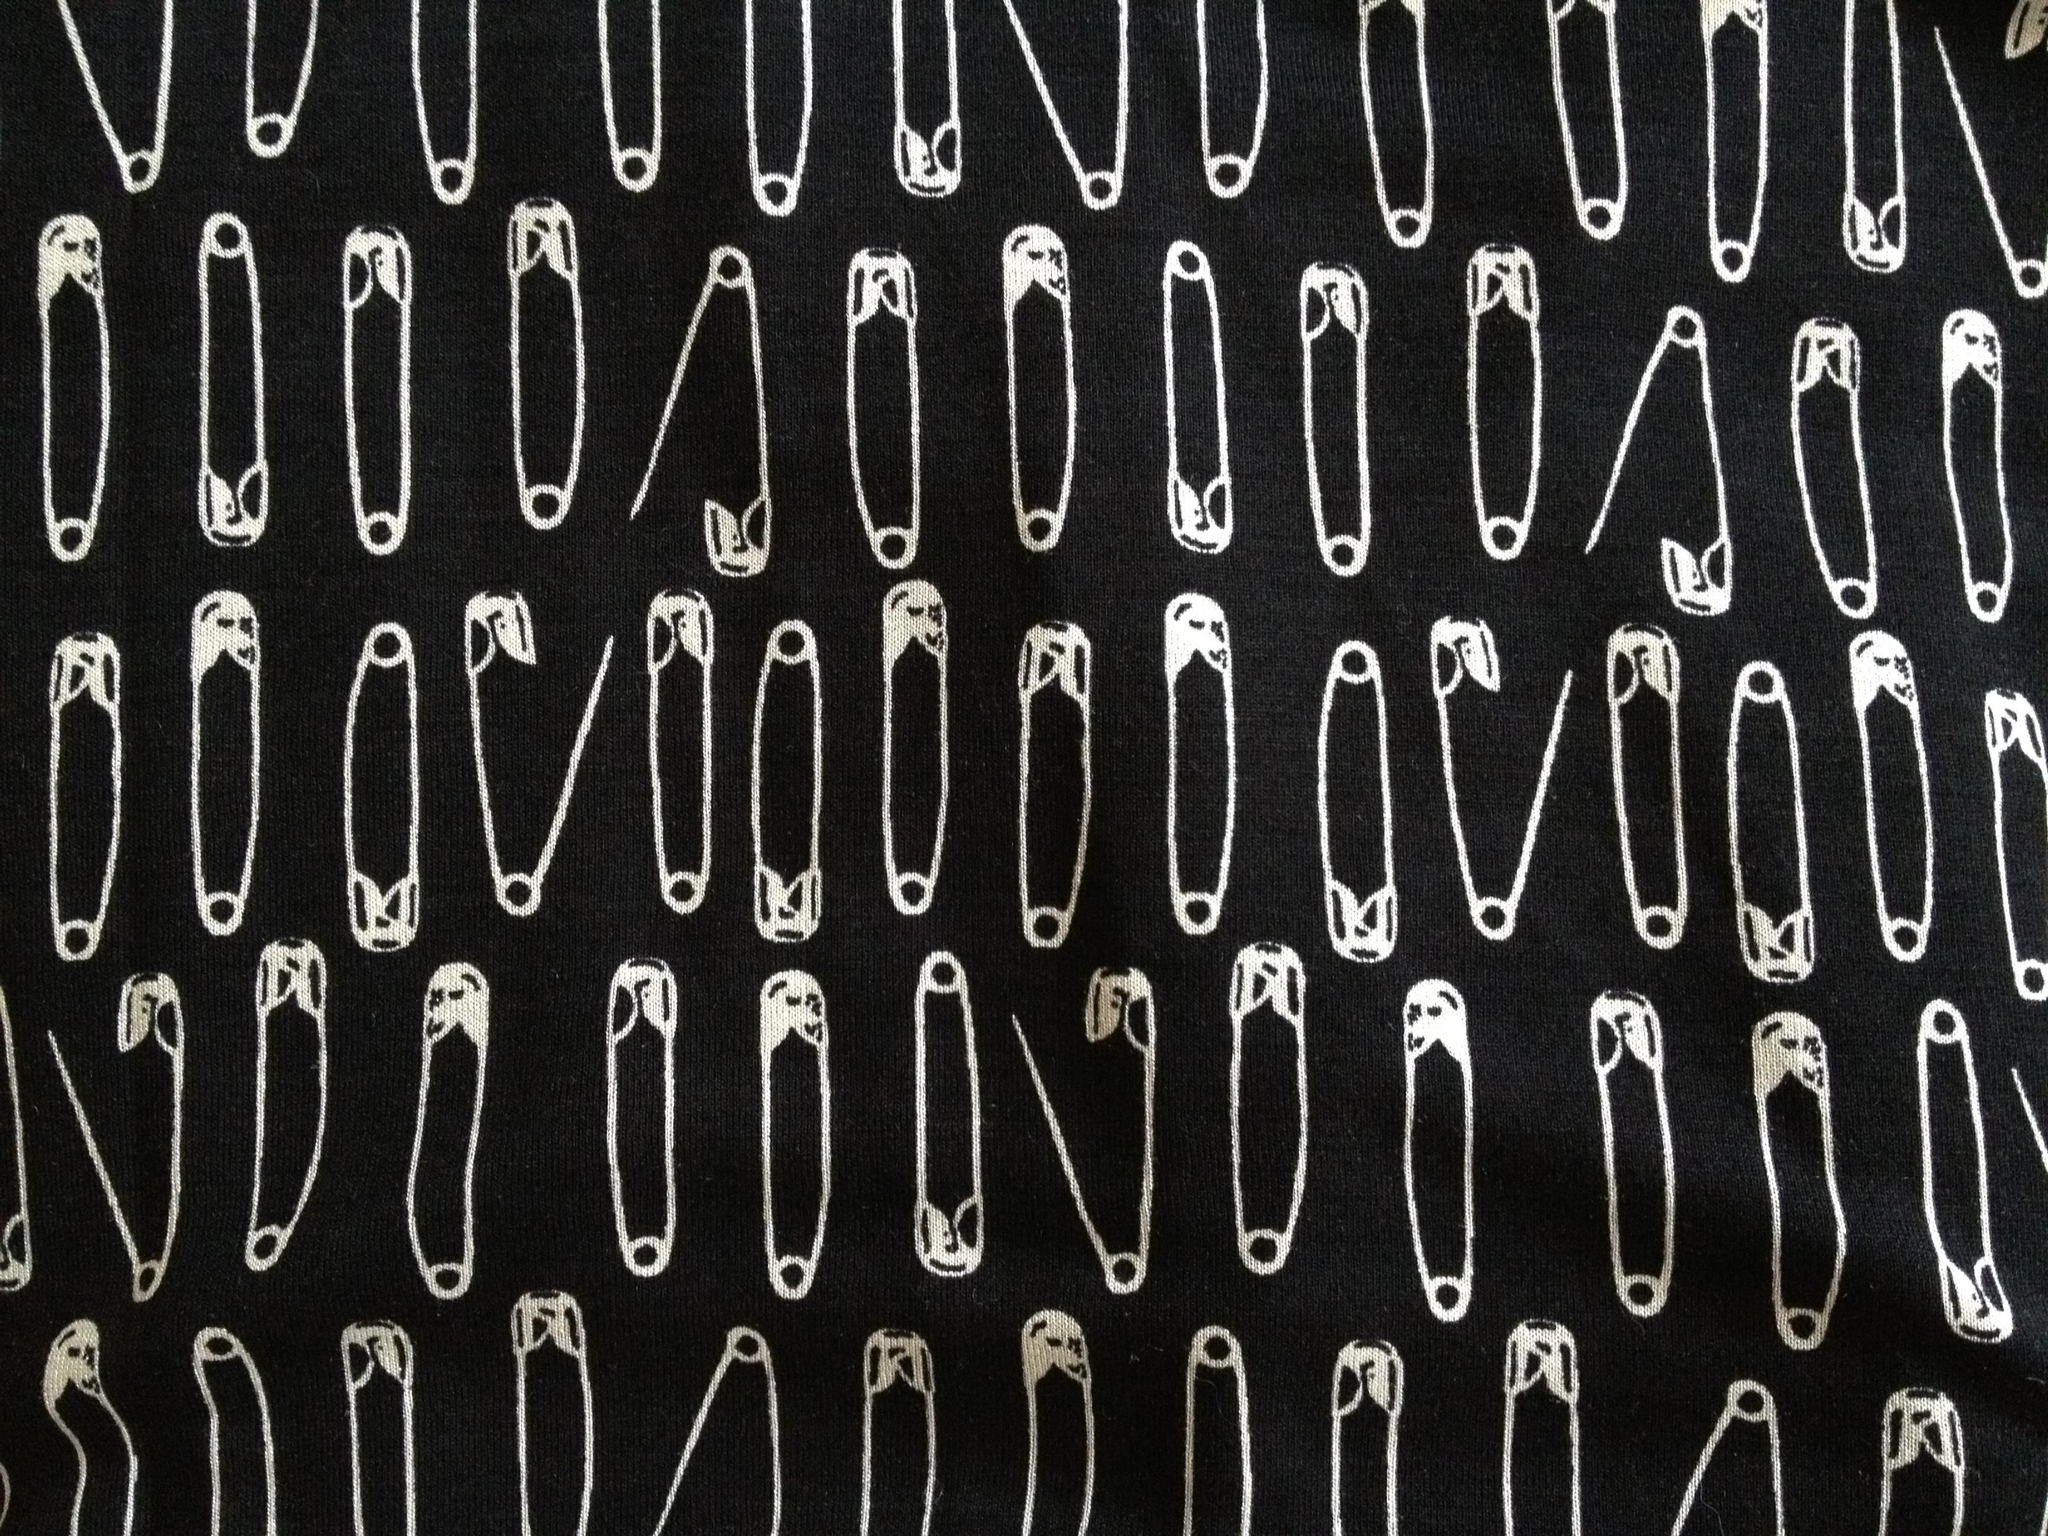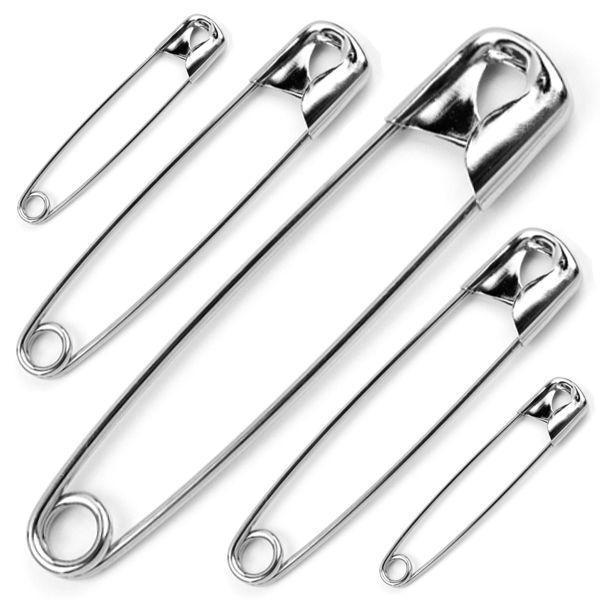The first image is the image on the left, the second image is the image on the right. Evaluate the accuracy of this statement regarding the images: "In one image, safety pins are arranged from small to large and back to small sizes.". Is it true? Answer yes or no. Yes. 